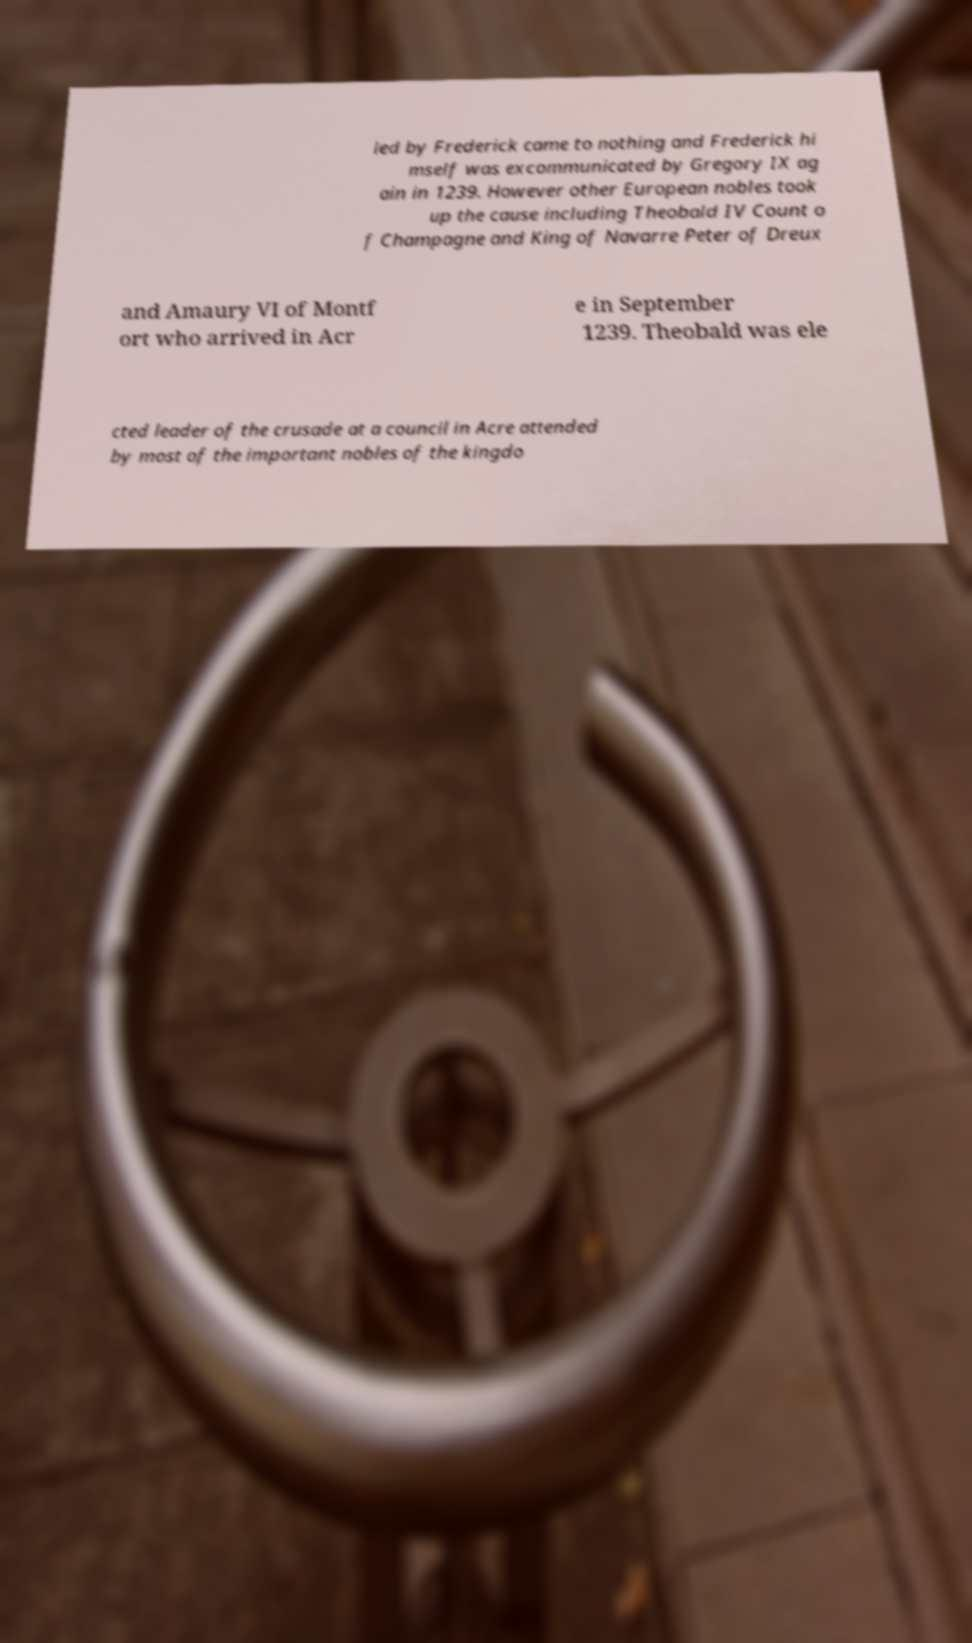What messages or text are displayed in this image? I need them in a readable, typed format. led by Frederick came to nothing and Frederick hi mself was excommunicated by Gregory IX ag ain in 1239. However other European nobles took up the cause including Theobald IV Count o f Champagne and King of Navarre Peter of Dreux and Amaury VI of Montf ort who arrived in Acr e in September 1239. Theobald was ele cted leader of the crusade at a council in Acre attended by most of the important nobles of the kingdo 